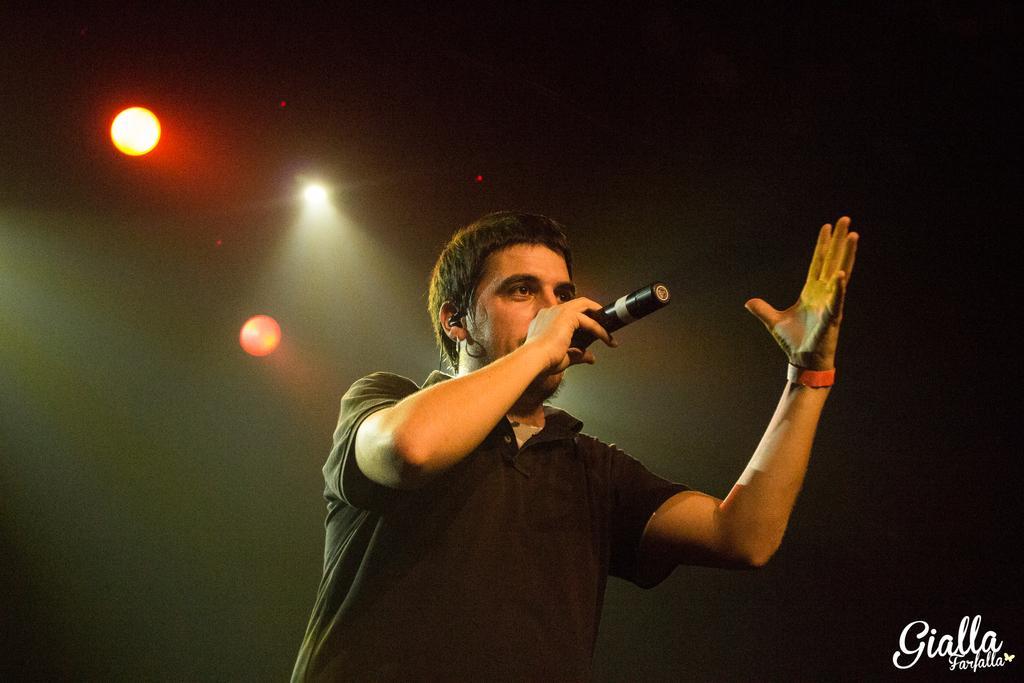Could you give a brief overview of what you see in this image? In this picture we see a man holding a mike and singing for someone. 